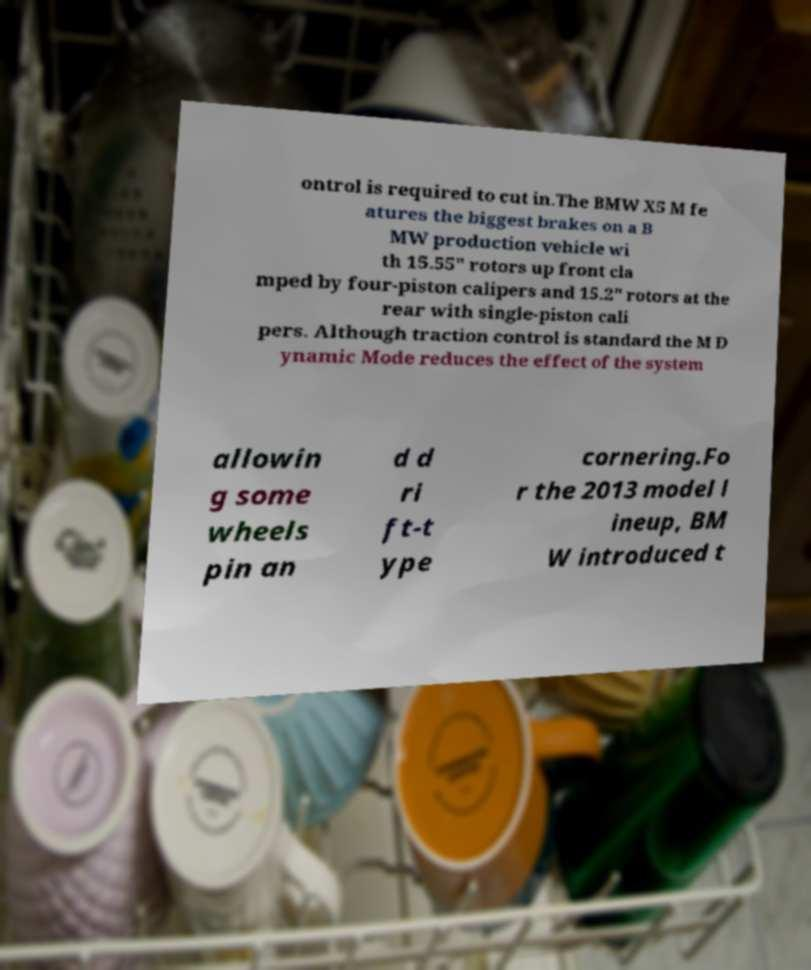For documentation purposes, I need the text within this image transcribed. Could you provide that? ontrol is required to cut in.The BMW X5 M fe atures the biggest brakes on a B MW production vehicle wi th 15.55" rotors up front cla mped by four-piston calipers and 15.2" rotors at the rear with single-piston cali pers. Although traction control is standard the M D ynamic Mode reduces the effect of the system allowin g some wheels pin an d d ri ft-t ype cornering.Fo r the 2013 model l ineup, BM W introduced t 